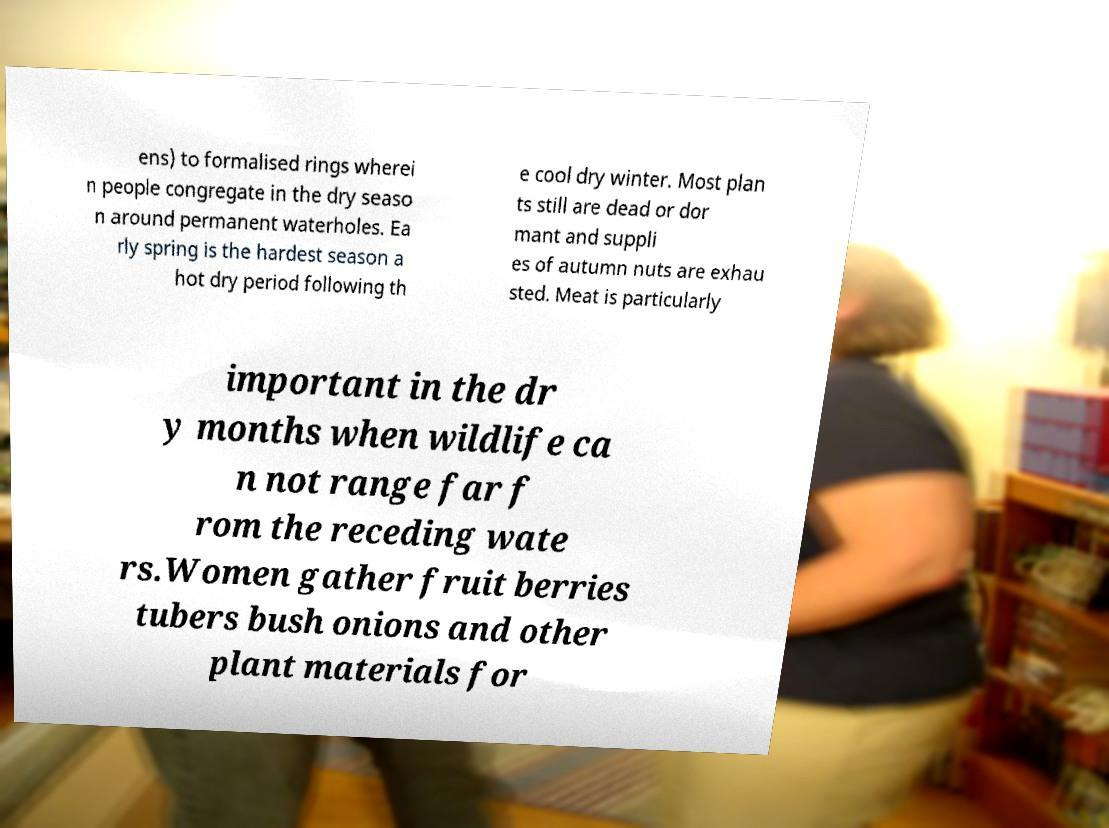Can you accurately transcribe the text from the provided image for me? ens) to formalised rings wherei n people congregate in the dry seaso n around permanent waterholes. Ea rly spring is the hardest season a hot dry period following th e cool dry winter. Most plan ts still are dead or dor mant and suppli es of autumn nuts are exhau sted. Meat is particularly important in the dr y months when wildlife ca n not range far f rom the receding wate rs.Women gather fruit berries tubers bush onions and other plant materials for 